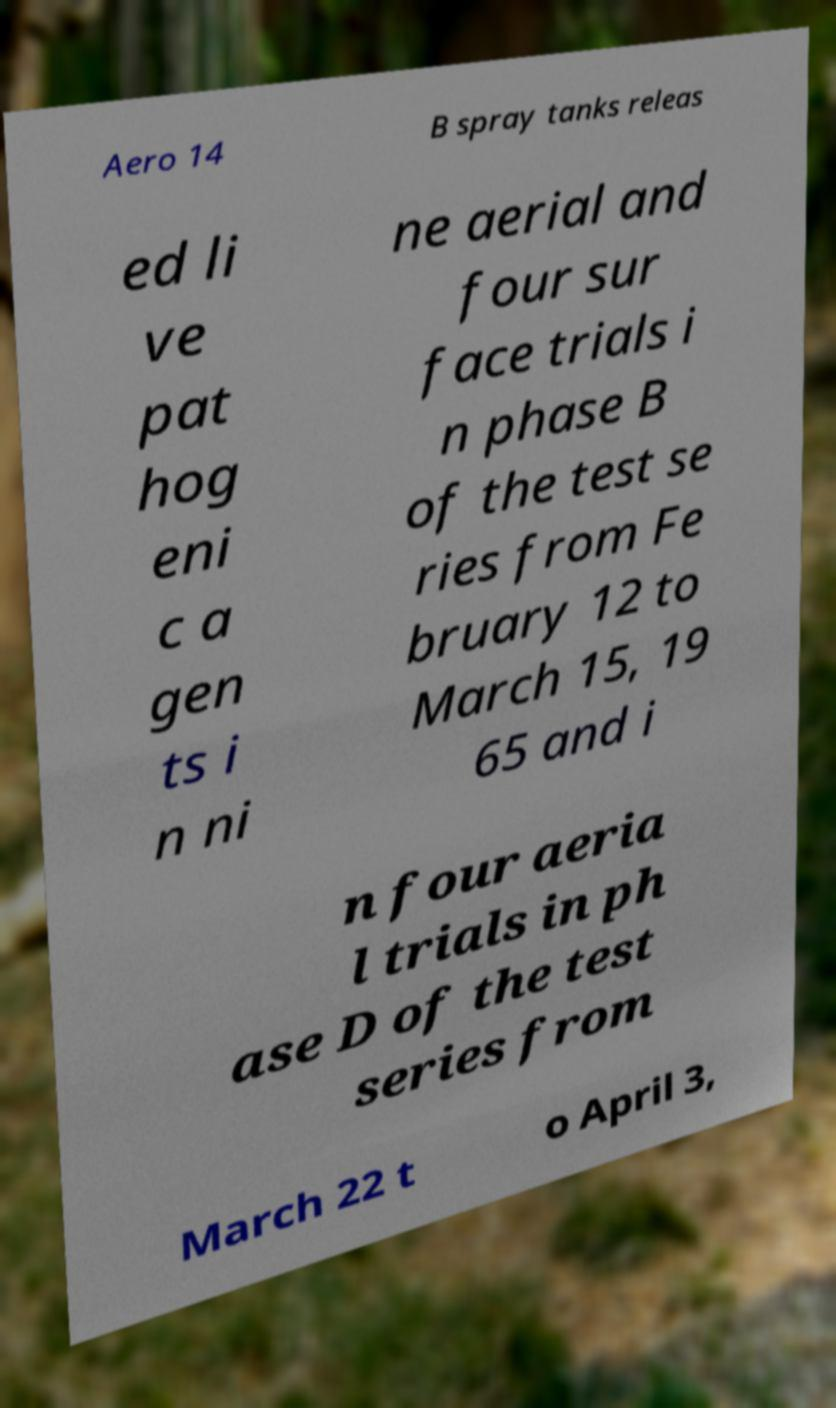For documentation purposes, I need the text within this image transcribed. Could you provide that? Aero 14 B spray tanks releas ed li ve pat hog eni c a gen ts i n ni ne aerial and four sur face trials i n phase B of the test se ries from Fe bruary 12 to March 15, 19 65 and i n four aeria l trials in ph ase D of the test series from March 22 t o April 3, 